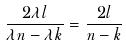<formula> <loc_0><loc_0><loc_500><loc_500>\frac { 2 \lambda l } { \lambda n - \lambda k } = \frac { 2 l } { n - k }</formula> 